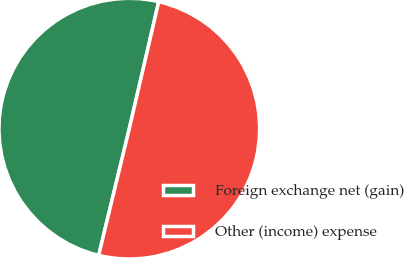<chart> <loc_0><loc_0><loc_500><loc_500><pie_chart><fcel>Foreign exchange net (gain)<fcel>Other (income) expense<nl><fcel>49.85%<fcel>50.15%<nl></chart> 